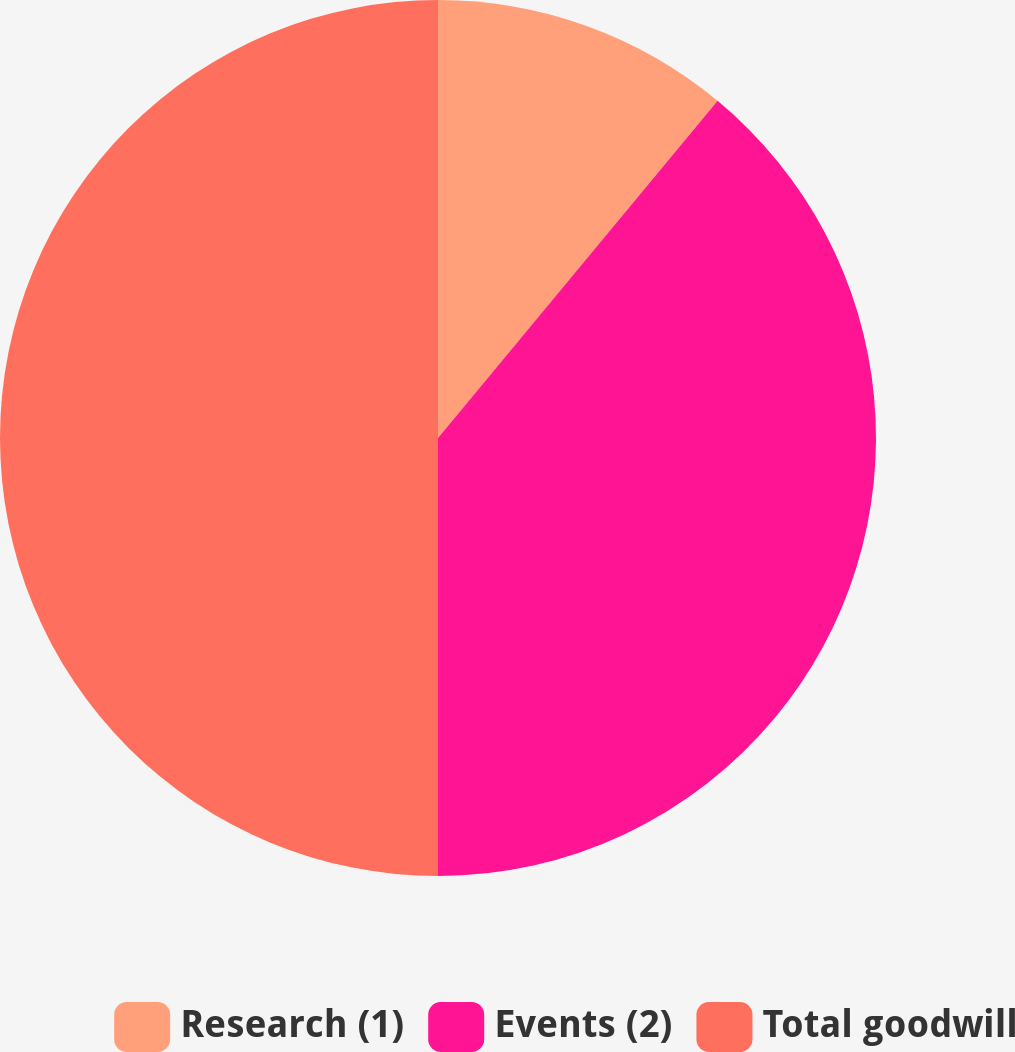<chart> <loc_0><loc_0><loc_500><loc_500><pie_chart><fcel>Research (1)<fcel>Events (2)<fcel>Total goodwill<nl><fcel>11.02%<fcel>38.98%<fcel>50.0%<nl></chart> 